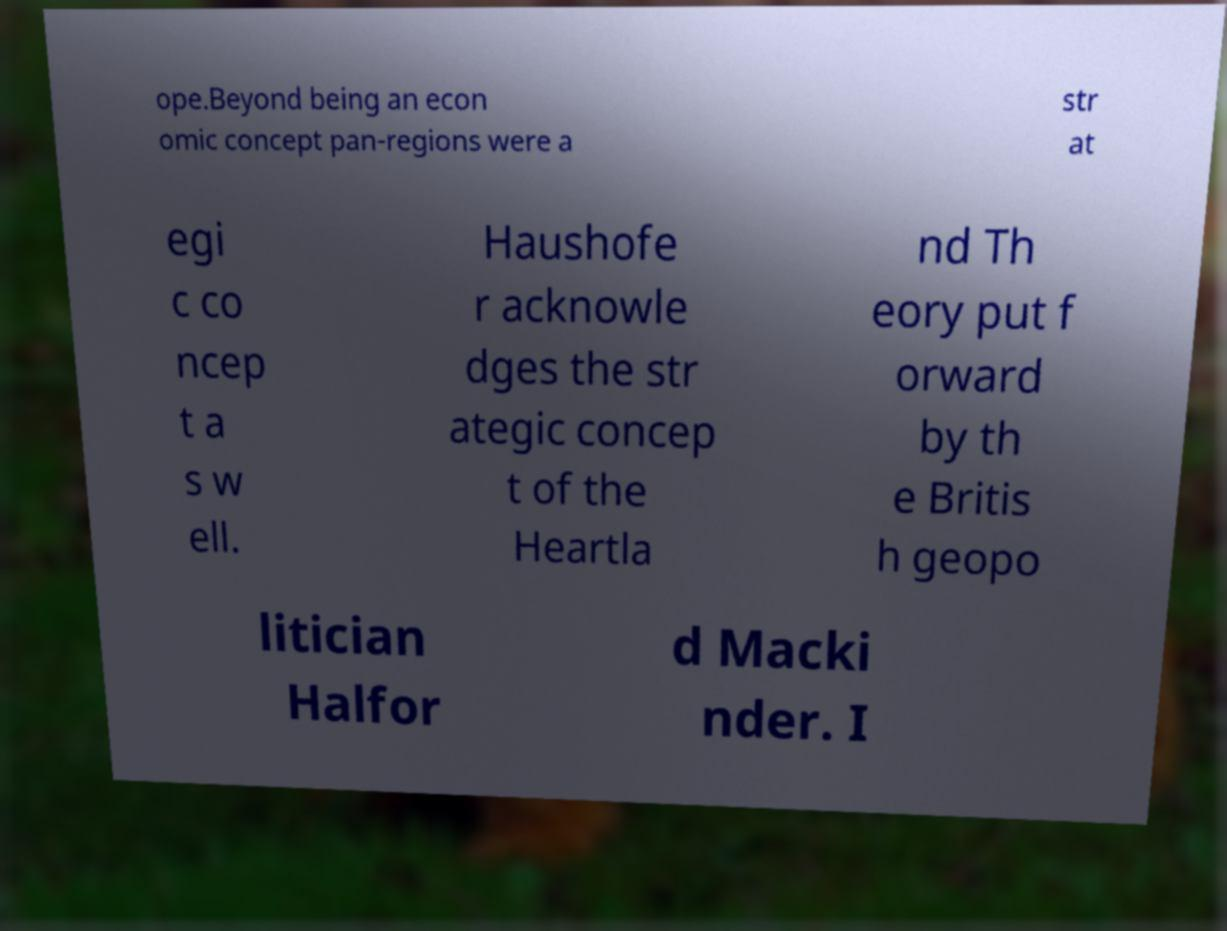For documentation purposes, I need the text within this image transcribed. Could you provide that? ope.Beyond being an econ omic concept pan-regions were a str at egi c co ncep t a s w ell. Haushofe r acknowle dges the str ategic concep t of the Heartla nd Th eory put f orward by th e Britis h geopo litician Halfor d Macki nder. I 